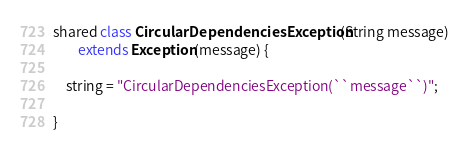<code> <loc_0><loc_0><loc_500><loc_500><_Ceylon_>
shared class CircularDependenciesException(String message)
		extends Exception(message) {
	
	string = "CircularDependenciesException(``message``)";
	
}</code> 